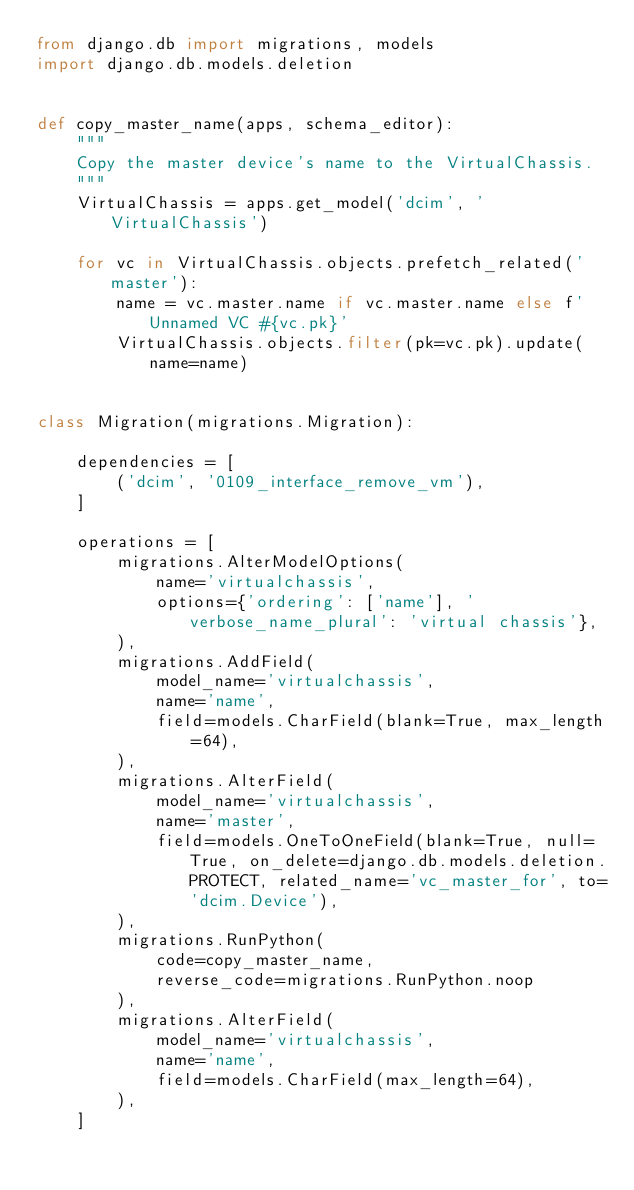Convert code to text. <code><loc_0><loc_0><loc_500><loc_500><_Python_>from django.db import migrations, models
import django.db.models.deletion


def copy_master_name(apps, schema_editor):
    """
    Copy the master device's name to the VirtualChassis.
    """
    VirtualChassis = apps.get_model('dcim', 'VirtualChassis')

    for vc in VirtualChassis.objects.prefetch_related('master'):
        name = vc.master.name if vc.master.name else f'Unnamed VC #{vc.pk}'
        VirtualChassis.objects.filter(pk=vc.pk).update(name=name)


class Migration(migrations.Migration):

    dependencies = [
        ('dcim', '0109_interface_remove_vm'),
    ]

    operations = [
        migrations.AlterModelOptions(
            name='virtualchassis',
            options={'ordering': ['name'], 'verbose_name_plural': 'virtual chassis'},
        ),
        migrations.AddField(
            model_name='virtualchassis',
            name='name',
            field=models.CharField(blank=True, max_length=64),
        ),
        migrations.AlterField(
            model_name='virtualchassis',
            name='master',
            field=models.OneToOneField(blank=True, null=True, on_delete=django.db.models.deletion.PROTECT, related_name='vc_master_for', to='dcim.Device'),
        ),
        migrations.RunPython(
            code=copy_master_name,
            reverse_code=migrations.RunPython.noop
        ),
        migrations.AlterField(
            model_name='virtualchassis',
            name='name',
            field=models.CharField(max_length=64),
        ),
    ]
</code> 